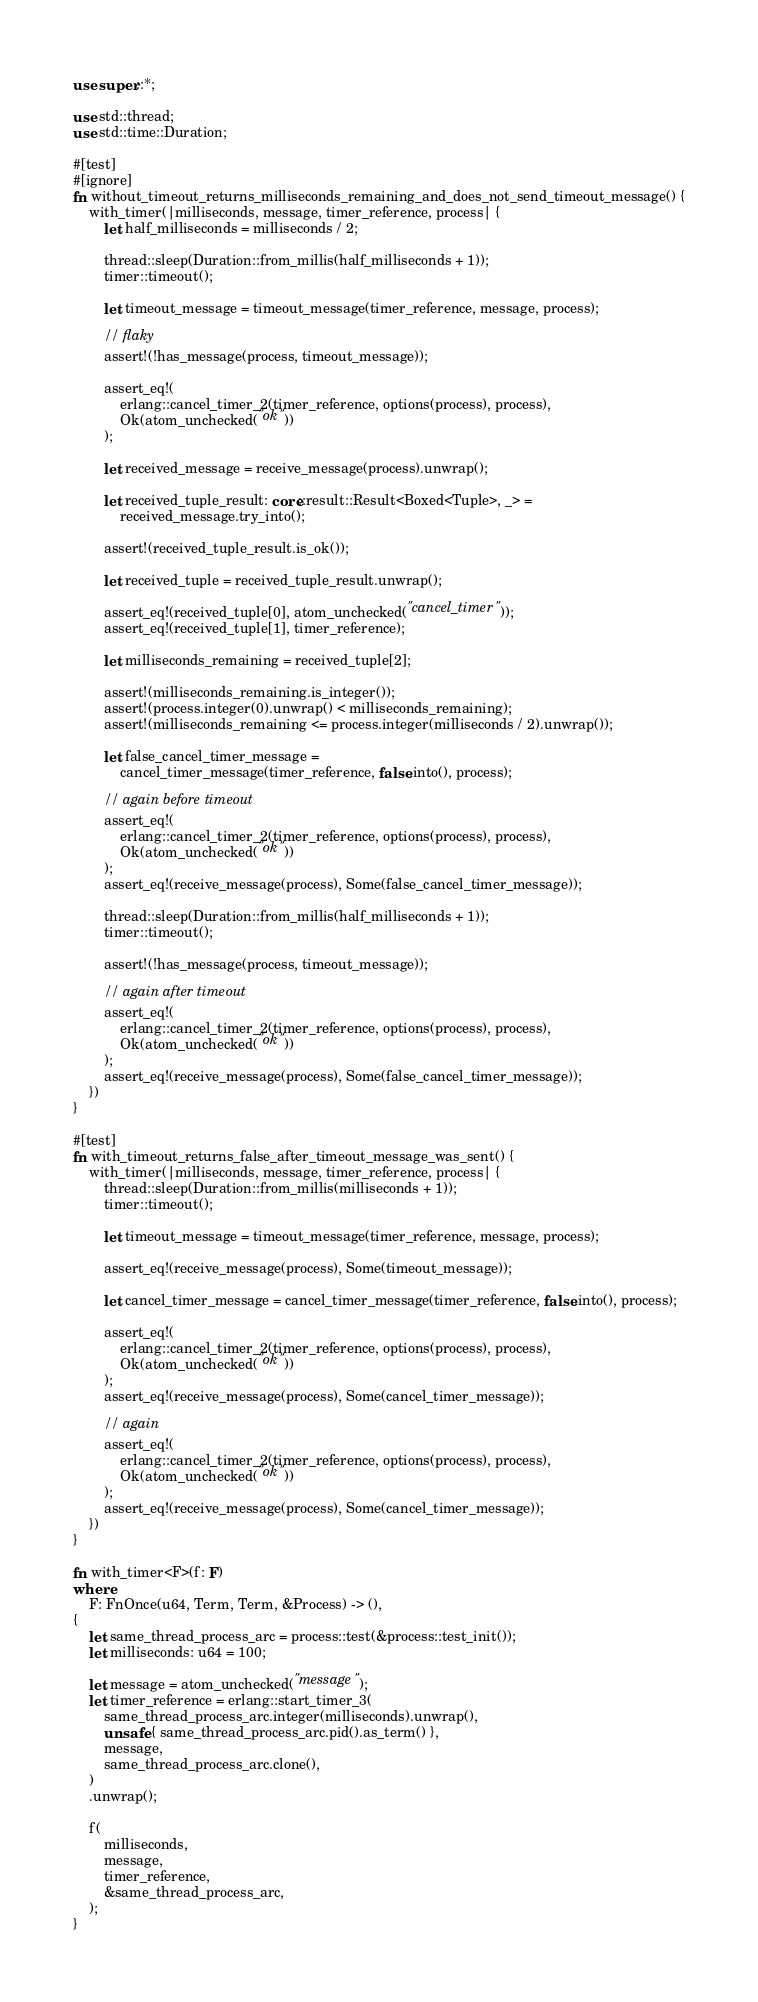<code> <loc_0><loc_0><loc_500><loc_500><_Rust_>use super::*;

use std::thread;
use std::time::Duration;

#[test]
#[ignore]
fn without_timeout_returns_milliseconds_remaining_and_does_not_send_timeout_message() {
    with_timer(|milliseconds, message, timer_reference, process| {
        let half_milliseconds = milliseconds / 2;

        thread::sleep(Duration::from_millis(half_milliseconds + 1));
        timer::timeout();

        let timeout_message = timeout_message(timer_reference, message, process);

        // flaky
        assert!(!has_message(process, timeout_message));

        assert_eq!(
            erlang::cancel_timer_2(timer_reference, options(process), process),
            Ok(atom_unchecked("ok"))
        );

        let received_message = receive_message(process).unwrap();

        let received_tuple_result: core::result::Result<Boxed<Tuple>, _> =
            received_message.try_into();

        assert!(received_tuple_result.is_ok());

        let received_tuple = received_tuple_result.unwrap();

        assert_eq!(received_tuple[0], atom_unchecked("cancel_timer"));
        assert_eq!(received_tuple[1], timer_reference);

        let milliseconds_remaining = received_tuple[2];

        assert!(milliseconds_remaining.is_integer());
        assert!(process.integer(0).unwrap() < milliseconds_remaining);
        assert!(milliseconds_remaining <= process.integer(milliseconds / 2).unwrap());

        let false_cancel_timer_message =
            cancel_timer_message(timer_reference, false.into(), process);

        // again before timeout
        assert_eq!(
            erlang::cancel_timer_2(timer_reference, options(process), process),
            Ok(atom_unchecked("ok"))
        );
        assert_eq!(receive_message(process), Some(false_cancel_timer_message));

        thread::sleep(Duration::from_millis(half_milliseconds + 1));
        timer::timeout();

        assert!(!has_message(process, timeout_message));

        // again after timeout
        assert_eq!(
            erlang::cancel_timer_2(timer_reference, options(process), process),
            Ok(atom_unchecked("ok"))
        );
        assert_eq!(receive_message(process), Some(false_cancel_timer_message));
    })
}

#[test]
fn with_timeout_returns_false_after_timeout_message_was_sent() {
    with_timer(|milliseconds, message, timer_reference, process| {
        thread::sleep(Duration::from_millis(milliseconds + 1));
        timer::timeout();

        let timeout_message = timeout_message(timer_reference, message, process);

        assert_eq!(receive_message(process), Some(timeout_message));

        let cancel_timer_message = cancel_timer_message(timer_reference, false.into(), process);

        assert_eq!(
            erlang::cancel_timer_2(timer_reference, options(process), process),
            Ok(atom_unchecked("ok"))
        );
        assert_eq!(receive_message(process), Some(cancel_timer_message));

        // again
        assert_eq!(
            erlang::cancel_timer_2(timer_reference, options(process), process),
            Ok(atom_unchecked("ok"))
        );
        assert_eq!(receive_message(process), Some(cancel_timer_message));
    })
}

fn with_timer<F>(f: F)
where
    F: FnOnce(u64, Term, Term, &Process) -> (),
{
    let same_thread_process_arc = process::test(&process::test_init());
    let milliseconds: u64 = 100;

    let message = atom_unchecked("message");
    let timer_reference = erlang::start_timer_3(
        same_thread_process_arc.integer(milliseconds).unwrap(),
        unsafe { same_thread_process_arc.pid().as_term() },
        message,
        same_thread_process_arc.clone(),
    )
    .unwrap();

    f(
        milliseconds,
        message,
        timer_reference,
        &same_thread_process_arc,
    );
}
</code> 